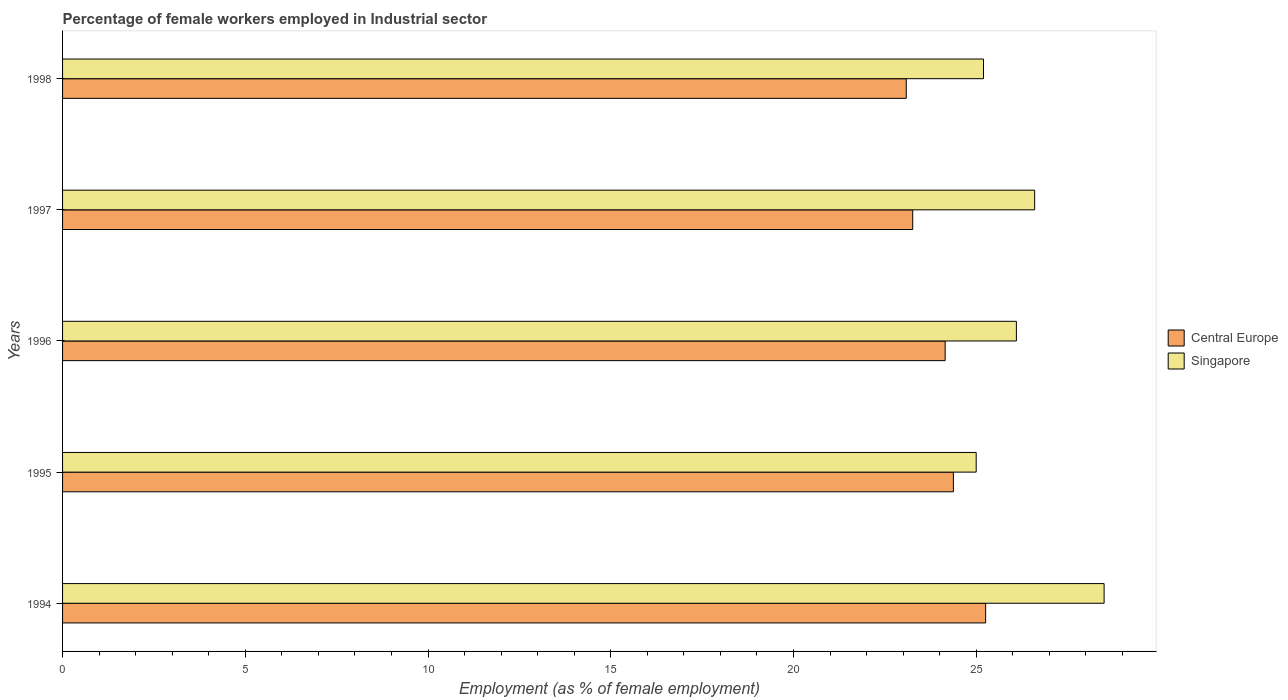How many different coloured bars are there?
Your answer should be compact. 2. Are the number of bars per tick equal to the number of legend labels?
Your answer should be very brief. Yes. How many bars are there on the 4th tick from the top?
Your answer should be compact. 2. How many bars are there on the 1st tick from the bottom?
Offer a very short reply. 2. What is the percentage of females employed in Industrial sector in Singapore in 1996?
Offer a terse response. 26.1. Across all years, what is the minimum percentage of females employed in Industrial sector in Central Europe?
Keep it short and to the point. 23.09. What is the total percentage of females employed in Industrial sector in Central Europe in the graph?
Give a very brief answer. 120.13. What is the difference between the percentage of females employed in Industrial sector in Central Europe in 1994 and that in 1998?
Offer a terse response. 2.17. What is the difference between the percentage of females employed in Industrial sector in Singapore in 1994 and the percentage of females employed in Industrial sector in Central Europe in 1995?
Make the answer very short. 4.12. What is the average percentage of females employed in Industrial sector in Singapore per year?
Offer a very short reply. 26.28. In the year 1995, what is the difference between the percentage of females employed in Industrial sector in Singapore and percentage of females employed in Industrial sector in Central Europe?
Your response must be concise. 0.62. What is the ratio of the percentage of females employed in Industrial sector in Singapore in 1995 to that in 1998?
Ensure brevity in your answer.  0.99. Is the percentage of females employed in Industrial sector in Central Europe in 1994 less than that in 1995?
Provide a succinct answer. No. What is the difference between the highest and the second highest percentage of females employed in Industrial sector in Singapore?
Your answer should be very brief. 1.9. What is the difference between the highest and the lowest percentage of females employed in Industrial sector in Central Europe?
Offer a very short reply. 2.17. What does the 2nd bar from the top in 1996 represents?
Give a very brief answer. Central Europe. What does the 1st bar from the bottom in 1996 represents?
Provide a succinct answer. Central Europe. How many bars are there?
Offer a terse response. 10. What is the difference between two consecutive major ticks on the X-axis?
Your response must be concise. 5. Does the graph contain grids?
Provide a succinct answer. No. Where does the legend appear in the graph?
Give a very brief answer. Center right. How are the legend labels stacked?
Provide a short and direct response. Vertical. What is the title of the graph?
Provide a succinct answer. Percentage of female workers employed in Industrial sector. What is the label or title of the X-axis?
Your answer should be compact. Employment (as % of female employment). What is the Employment (as % of female employment) of Central Europe in 1994?
Keep it short and to the point. 25.26. What is the Employment (as % of female employment) of Central Europe in 1995?
Your response must be concise. 24.38. What is the Employment (as % of female employment) in Central Europe in 1996?
Make the answer very short. 24.15. What is the Employment (as % of female employment) in Singapore in 1996?
Ensure brevity in your answer.  26.1. What is the Employment (as % of female employment) in Central Europe in 1997?
Offer a terse response. 23.26. What is the Employment (as % of female employment) of Singapore in 1997?
Offer a very short reply. 26.6. What is the Employment (as % of female employment) of Central Europe in 1998?
Provide a short and direct response. 23.09. What is the Employment (as % of female employment) of Singapore in 1998?
Provide a short and direct response. 25.2. Across all years, what is the maximum Employment (as % of female employment) of Central Europe?
Make the answer very short. 25.26. Across all years, what is the minimum Employment (as % of female employment) in Central Europe?
Keep it short and to the point. 23.09. What is the total Employment (as % of female employment) in Central Europe in the graph?
Your answer should be compact. 120.13. What is the total Employment (as % of female employment) of Singapore in the graph?
Give a very brief answer. 131.4. What is the difference between the Employment (as % of female employment) of Central Europe in 1994 and that in 1995?
Offer a terse response. 0.88. What is the difference between the Employment (as % of female employment) of Central Europe in 1994 and that in 1996?
Your answer should be very brief. 1.11. What is the difference between the Employment (as % of female employment) in Singapore in 1994 and that in 1996?
Your response must be concise. 2.4. What is the difference between the Employment (as % of female employment) of Central Europe in 1994 and that in 1997?
Ensure brevity in your answer.  2. What is the difference between the Employment (as % of female employment) of Central Europe in 1994 and that in 1998?
Offer a very short reply. 2.17. What is the difference between the Employment (as % of female employment) of Singapore in 1994 and that in 1998?
Provide a succinct answer. 3.3. What is the difference between the Employment (as % of female employment) of Central Europe in 1995 and that in 1996?
Give a very brief answer. 0.23. What is the difference between the Employment (as % of female employment) in Singapore in 1995 and that in 1996?
Your answer should be very brief. -1.1. What is the difference between the Employment (as % of female employment) in Central Europe in 1995 and that in 1997?
Keep it short and to the point. 1.11. What is the difference between the Employment (as % of female employment) of Central Europe in 1995 and that in 1998?
Give a very brief answer. 1.29. What is the difference between the Employment (as % of female employment) in Singapore in 1995 and that in 1998?
Make the answer very short. -0.2. What is the difference between the Employment (as % of female employment) in Central Europe in 1996 and that in 1997?
Provide a succinct answer. 0.89. What is the difference between the Employment (as % of female employment) of Singapore in 1996 and that in 1997?
Provide a short and direct response. -0.5. What is the difference between the Employment (as % of female employment) of Central Europe in 1996 and that in 1998?
Offer a terse response. 1.06. What is the difference between the Employment (as % of female employment) of Singapore in 1996 and that in 1998?
Your answer should be compact. 0.9. What is the difference between the Employment (as % of female employment) of Central Europe in 1997 and that in 1998?
Your response must be concise. 0.18. What is the difference between the Employment (as % of female employment) of Singapore in 1997 and that in 1998?
Give a very brief answer. 1.4. What is the difference between the Employment (as % of female employment) in Central Europe in 1994 and the Employment (as % of female employment) in Singapore in 1995?
Ensure brevity in your answer.  0.26. What is the difference between the Employment (as % of female employment) in Central Europe in 1994 and the Employment (as % of female employment) in Singapore in 1996?
Offer a terse response. -0.84. What is the difference between the Employment (as % of female employment) of Central Europe in 1994 and the Employment (as % of female employment) of Singapore in 1997?
Ensure brevity in your answer.  -1.34. What is the difference between the Employment (as % of female employment) in Central Europe in 1994 and the Employment (as % of female employment) in Singapore in 1998?
Provide a succinct answer. 0.06. What is the difference between the Employment (as % of female employment) of Central Europe in 1995 and the Employment (as % of female employment) of Singapore in 1996?
Your answer should be very brief. -1.72. What is the difference between the Employment (as % of female employment) of Central Europe in 1995 and the Employment (as % of female employment) of Singapore in 1997?
Offer a terse response. -2.22. What is the difference between the Employment (as % of female employment) in Central Europe in 1995 and the Employment (as % of female employment) in Singapore in 1998?
Give a very brief answer. -0.82. What is the difference between the Employment (as % of female employment) of Central Europe in 1996 and the Employment (as % of female employment) of Singapore in 1997?
Ensure brevity in your answer.  -2.45. What is the difference between the Employment (as % of female employment) in Central Europe in 1996 and the Employment (as % of female employment) in Singapore in 1998?
Keep it short and to the point. -1.05. What is the difference between the Employment (as % of female employment) of Central Europe in 1997 and the Employment (as % of female employment) of Singapore in 1998?
Keep it short and to the point. -1.94. What is the average Employment (as % of female employment) in Central Europe per year?
Your response must be concise. 24.03. What is the average Employment (as % of female employment) in Singapore per year?
Provide a short and direct response. 26.28. In the year 1994, what is the difference between the Employment (as % of female employment) of Central Europe and Employment (as % of female employment) of Singapore?
Offer a very short reply. -3.24. In the year 1995, what is the difference between the Employment (as % of female employment) of Central Europe and Employment (as % of female employment) of Singapore?
Your answer should be very brief. -0.62. In the year 1996, what is the difference between the Employment (as % of female employment) of Central Europe and Employment (as % of female employment) of Singapore?
Keep it short and to the point. -1.95. In the year 1997, what is the difference between the Employment (as % of female employment) in Central Europe and Employment (as % of female employment) in Singapore?
Provide a succinct answer. -3.34. In the year 1998, what is the difference between the Employment (as % of female employment) in Central Europe and Employment (as % of female employment) in Singapore?
Offer a terse response. -2.11. What is the ratio of the Employment (as % of female employment) of Central Europe in 1994 to that in 1995?
Provide a short and direct response. 1.04. What is the ratio of the Employment (as % of female employment) in Singapore in 1994 to that in 1995?
Your answer should be very brief. 1.14. What is the ratio of the Employment (as % of female employment) in Central Europe in 1994 to that in 1996?
Provide a succinct answer. 1.05. What is the ratio of the Employment (as % of female employment) of Singapore in 1994 to that in 1996?
Provide a short and direct response. 1.09. What is the ratio of the Employment (as % of female employment) of Central Europe in 1994 to that in 1997?
Your answer should be compact. 1.09. What is the ratio of the Employment (as % of female employment) in Singapore in 1994 to that in 1997?
Keep it short and to the point. 1.07. What is the ratio of the Employment (as % of female employment) of Central Europe in 1994 to that in 1998?
Provide a succinct answer. 1.09. What is the ratio of the Employment (as % of female employment) in Singapore in 1994 to that in 1998?
Offer a very short reply. 1.13. What is the ratio of the Employment (as % of female employment) in Central Europe in 1995 to that in 1996?
Offer a terse response. 1.01. What is the ratio of the Employment (as % of female employment) of Singapore in 1995 to that in 1996?
Your response must be concise. 0.96. What is the ratio of the Employment (as % of female employment) of Central Europe in 1995 to that in 1997?
Provide a succinct answer. 1.05. What is the ratio of the Employment (as % of female employment) of Singapore in 1995 to that in 1997?
Provide a succinct answer. 0.94. What is the ratio of the Employment (as % of female employment) of Central Europe in 1995 to that in 1998?
Your response must be concise. 1.06. What is the ratio of the Employment (as % of female employment) of Singapore in 1995 to that in 1998?
Your answer should be very brief. 0.99. What is the ratio of the Employment (as % of female employment) of Central Europe in 1996 to that in 1997?
Offer a very short reply. 1.04. What is the ratio of the Employment (as % of female employment) of Singapore in 1996 to that in 1997?
Offer a terse response. 0.98. What is the ratio of the Employment (as % of female employment) of Central Europe in 1996 to that in 1998?
Your response must be concise. 1.05. What is the ratio of the Employment (as % of female employment) in Singapore in 1996 to that in 1998?
Provide a succinct answer. 1.04. What is the ratio of the Employment (as % of female employment) in Central Europe in 1997 to that in 1998?
Offer a very short reply. 1.01. What is the ratio of the Employment (as % of female employment) of Singapore in 1997 to that in 1998?
Give a very brief answer. 1.06. What is the difference between the highest and the second highest Employment (as % of female employment) of Central Europe?
Give a very brief answer. 0.88. What is the difference between the highest and the second highest Employment (as % of female employment) in Singapore?
Provide a succinct answer. 1.9. What is the difference between the highest and the lowest Employment (as % of female employment) of Central Europe?
Your answer should be compact. 2.17. What is the difference between the highest and the lowest Employment (as % of female employment) in Singapore?
Offer a very short reply. 3.5. 